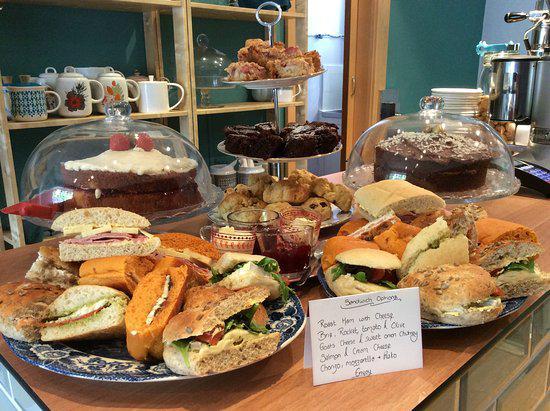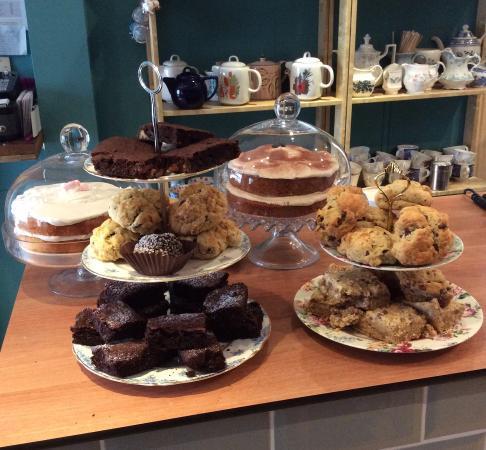The first image is the image on the left, the second image is the image on the right. Assess this claim about the two images: "At least one saucer in the image on the left has a coffee cup on top of it.". Correct or not? Answer yes or no. No. The first image is the image on the left, the second image is the image on the right. For the images displayed, is the sentence "Each image features baked treats displayed on tiered plates, and porcelain teapots are in the background of at least one image." factually correct? Answer yes or no. Yes. 